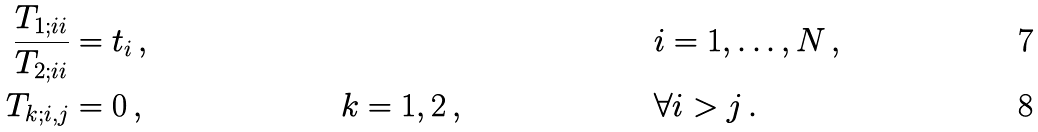Convert formula to latex. <formula><loc_0><loc_0><loc_500><loc_500>\frac { T _ { 1 ; i i } } { T _ { 2 ; i i } } & = t _ { i } \, , & & & & i = 1 , \dots , N \, , \\ T _ { k ; i , j } & = 0 \, , & & k = 1 , 2 \, , & & \forall i > j \, .</formula> 